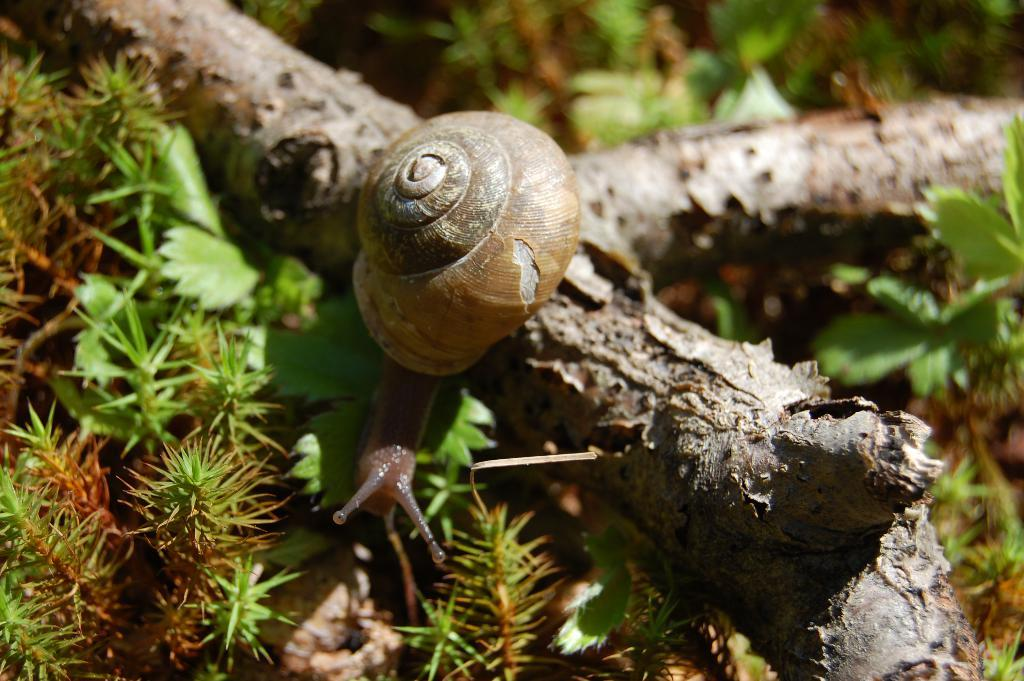What is the main subject of the image? There is a snail in the image. Where is the snail located? The snail is on a wooden trunk. What can be seen in the background of the image? There are plants in the background of the image. How many slaves are visible in the image? There are no slaves present in the image; it features a snail on a wooden trunk with plants in the background. What type of chess piece is the snail mimicking in the image? There is no chess piece or any reference to chess in the image; it features a snail on a wooden trunk with plants in the background. 